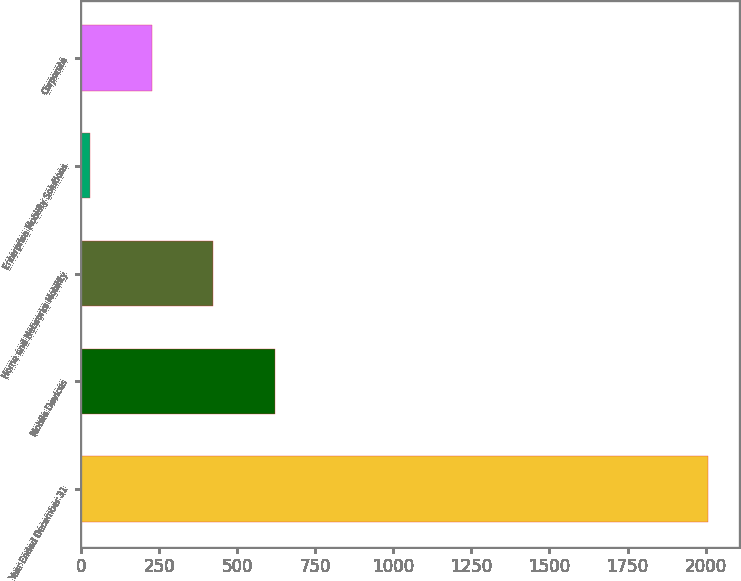<chart> <loc_0><loc_0><loc_500><loc_500><bar_chart><fcel>Year Ended December 31<fcel>Mobile Devices<fcel>Home and Networks Mobility<fcel>Enterprise Mobility Solutions<fcel>Corporate<nl><fcel>2008<fcel>621.3<fcel>423.2<fcel>27<fcel>225.1<nl></chart> 